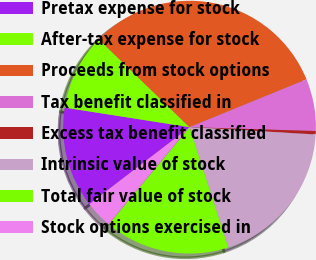Convert chart. <chart><loc_0><loc_0><loc_500><loc_500><pie_chart><fcel>Pretax expense for stock<fcel>After-tax expense for stock<fcel>Proceeds from stock options<fcel>Tax benefit classified in<fcel>Excess tax benefit classified<fcel>Intrinsic value of stock<fcel>Total fair value of stock<fcel>Stock options exercised in<nl><fcel>12.89%<fcel>9.77%<fcel>31.58%<fcel>6.66%<fcel>0.43%<fcel>19.12%<fcel>16.01%<fcel>3.54%<nl></chart> 